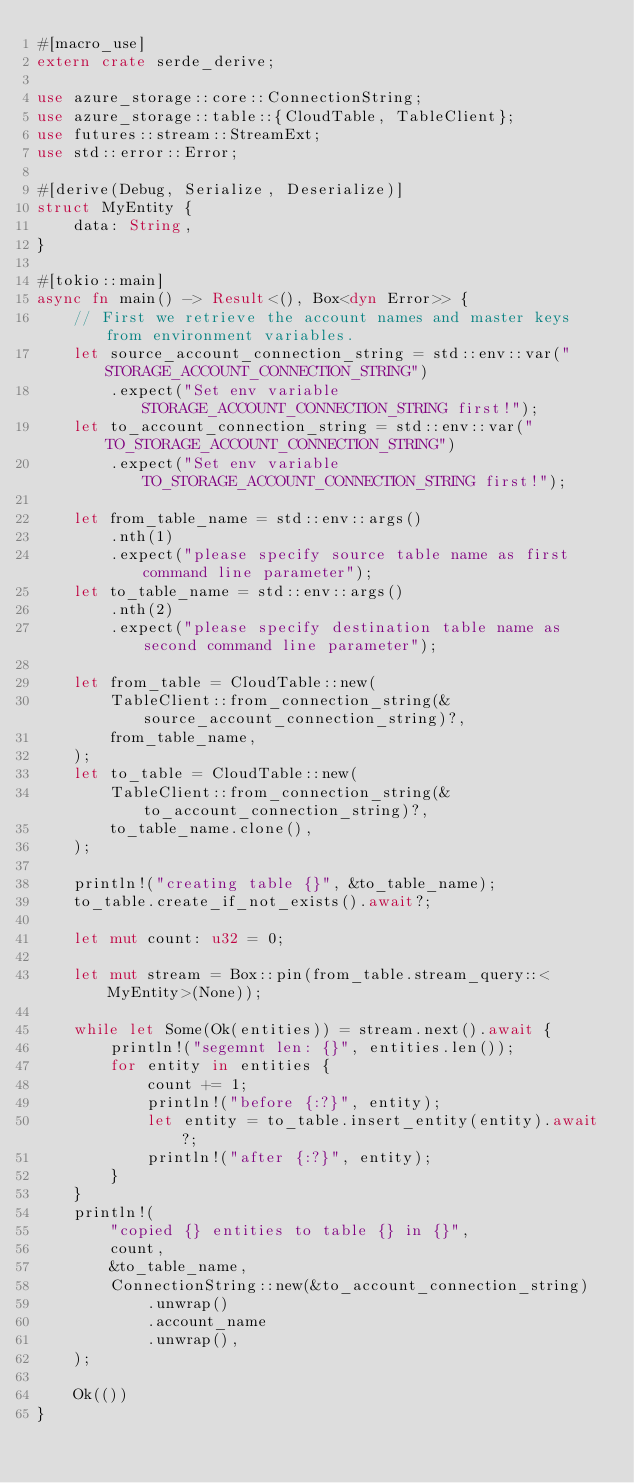<code> <loc_0><loc_0><loc_500><loc_500><_Rust_>#[macro_use]
extern crate serde_derive;

use azure_storage::core::ConnectionString;
use azure_storage::table::{CloudTable, TableClient};
use futures::stream::StreamExt;
use std::error::Error;

#[derive(Debug, Serialize, Deserialize)]
struct MyEntity {
    data: String,
}

#[tokio::main]
async fn main() -> Result<(), Box<dyn Error>> {
    // First we retrieve the account names and master keys from environment variables.
    let source_account_connection_string = std::env::var("STORAGE_ACCOUNT_CONNECTION_STRING")
        .expect("Set env variable STORAGE_ACCOUNT_CONNECTION_STRING first!");
    let to_account_connection_string = std::env::var("TO_STORAGE_ACCOUNT_CONNECTION_STRING")
        .expect("Set env variable TO_STORAGE_ACCOUNT_CONNECTION_STRING first!");

    let from_table_name = std::env::args()
        .nth(1)
        .expect("please specify source table name as first command line parameter");
    let to_table_name = std::env::args()
        .nth(2)
        .expect("please specify destination table name as second command line parameter");

    let from_table = CloudTable::new(
        TableClient::from_connection_string(&source_account_connection_string)?,
        from_table_name,
    );
    let to_table = CloudTable::new(
        TableClient::from_connection_string(&to_account_connection_string)?,
        to_table_name.clone(),
    );

    println!("creating table {}", &to_table_name);
    to_table.create_if_not_exists().await?;

    let mut count: u32 = 0;

    let mut stream = Box::pin(from_table.stream_query::<MyEntity>(None));

    while let Some(Ok(entities)) = stream.next().await {
        println!("segemnt len: {}", entities.len());
        for entity in entities {
            count += 1;
            println!("before {:?}", entity);
            let entity = to_table.insert_entity(entity).await?;
            println!("after {:?}", entity);
        }
    }
    println!(
        "copied {} entities to table {} in {}",
        count,
        &to_table_name,
        ConnectionString::new(&to_account_connection_string)
            .unwrap()
            .account_name
            .unwrap(),
    );

    Ok(())
}
</code> 